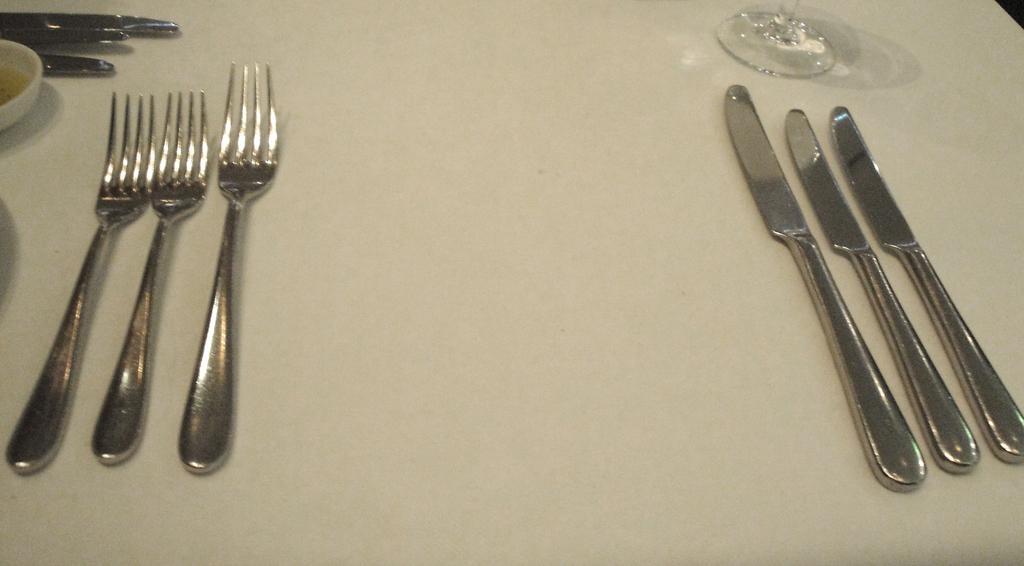How would you summarize this image in a sentence or two? In this picture we can see few forks, knives, glass and other things on the table. 